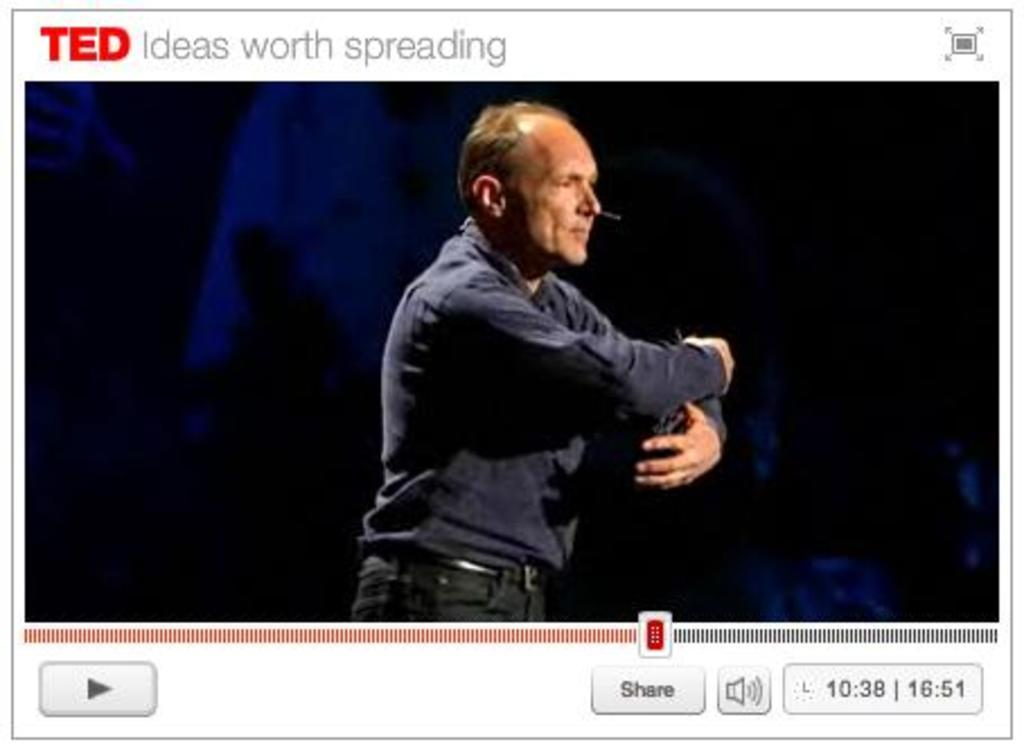What is the main subject of the image? There is a man in the middle of the image. What is the man wearing? The man is wearing a shirt, a belt, and trousers. Where can text be found in the image? There is text at the bottom and top of the image. What type of cap is the secretary wearing in the image? There is no secretary or cap present in the image. Can you describe the rose that is being held by the man in the image? There is no rose present in the image; the man is not holding any object. 